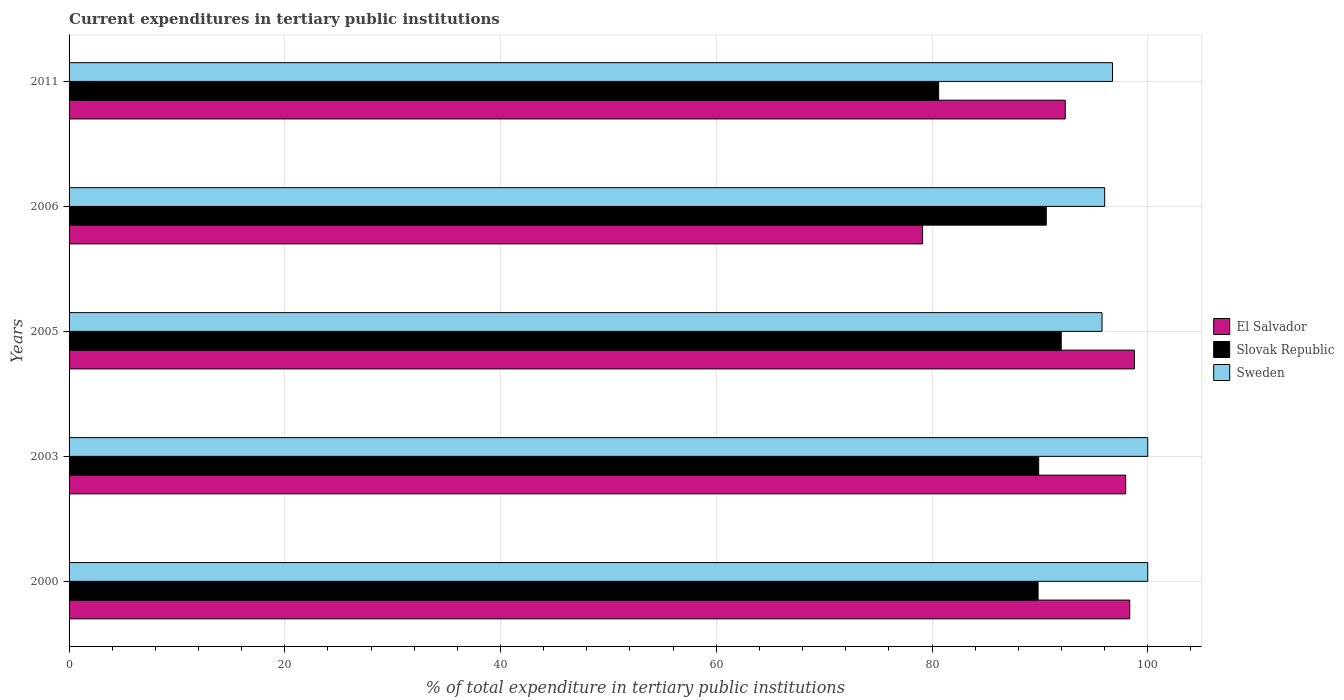How many different coloured bars are there?
Ensure brevity in your answer.  3. Are the number of bars on each tick of the Y-axis equal?
Provide a short and direct response. Yes. How many bars are there on the 4th tick from the top?
Make the answer very short. 3. How many bars are there on the 5th tick from the bottom?
Offer a terse response. 3. What is the label of the 1st group of bars from the top?
Your answer should be very brief. 2011. What is the current expenditures in tertiary public institutions in Slovak Republic in 2000?
Ensure brevity in your answer.  89.83. Across all years, what is the maximum current expenditures in tertiary public institutions in El Salvador?
Your response must be concise. 98.76. Across all years, what is the minimum current expenditures in tertiary public institutions in Slovak Republic?
Provide a succinct answer. 80.62. In which year was the current expenditures in tertiary public institutions in Sweden maximum?
Provide a succinct answer. 2000. In which year was the current expenditures in tertiary public institutions in Sweden minimum?
Provide a short and direct response. 2005. What is the total current expenditures in tertiary public institutions in El Salvador in the graph?
Keep it short and to the point. 466.52. What is the difference between the current expenditures in tertiary public institutions in Sweden in 2005 and that in 2011?
Keep it short and to the point. -0.97. What is the difference between the current expenditures in tertiary public institutions in Sweden in 2005 and the current expenditures in tertiary public institutions in El Salvador in 2000?
Provide a succinct answer. -2.57. What is the average current expenditures in tertiary public institutions in Slovak Republic per year?
Give a very brief answer. 88.58. In the year 2006, what is the difference between the current expenditures in tertiary public institutions in El Salvador and current expenditures in tertiary public institutions in Slovak Republic?
Your answer should be compact. -11.47. What is the ratio of the current expenditures in tertiary public institutions in Slovak Republic in 2000 to that in 2006?
Offer a terse response. 0.99. Is the current expenditures in tertiary public institutions in Sweden in 2003 less than that in 2005?
Your answer should be very brief. No. Is the difference between the current expenditures in tertiary public institutions in El Salvador in 2006 and 2011 greater than the difference between the current expenditures in tertiary public institutions in Slovak Republic in 2006 and 2011?
Give a very brief answer. No. What is the difference between the highest and the second highest current expenditures in tertiary public institutions in Sweden?
Your response must be concise. 0. What is the difference between the highest and the lowest current expenditures in tertiary public institutions in El Salvador?
Your answer should be very brief. 19.63. In how many years, is the current expenditures in tertiary public institutions in Sweden greater than the average current expenditures in tertiary public institutions in Sweden taken over all years?
Keep it short and to the point. 2. Is the sum of the current expenditures in tertiary public institutions in Slovak Republic in 2003 and 2006 greater than the maximum current expenditures in tertiary public institutions in El Salvador across all years?
Keep it short and to the point. Yes. What does the 3rd bar from the top in 2006 represents?
Your answer should be compact. El Salvador. What does the 3rd bar from the bottom in 2000 represents?
Offer a very short reply. Sweden. Is it the case that in every year, the sum of the current expenditures in tertiary public institutions in El Salvador and current expenditures in tertiary public institutions in Sweden is greater than the current expenditures in tertiary public institutions in Slovak Republic?
Make the answer very short. Yes. How many years are there in the graph?
Make the answer very short. 5. Does the graph contain any zero values?
Provide a short and direct response. No. Does the graph contain grids?
Offer a very short reply. Yes. How many legend labels are there?
Offer a very short reply. 3. What is the title of the graph?
Ensure brevity in your answer.  Current expenditures in tertiary public institutions. What is the label or title of the X-axis?
Provide a succinct answer. % of total expenditure in tertiary public institutions. What is the % of total expenditure in tertiary public institutions of El Salvador in 2000?
Offer a very short reply. 98.33. What is the % of total expenditure in tertiary public institutions of Slovak Republic in 2000?
Ensure brevity in your answer.  89.83. What is the % of total expenditure in tertiary public institutions of El Salvador in 2003?
Give a very brief answer. 97.95. What is the % of total expenditure in tertiary public institutions of Slovak Republic in 2003?
Offer a very short reply. 89.89. What is the % of total expenditure in tertiary public institutions in El Salvador in 2005?
Provide a short and direct response. 98.76. What is the % of total expenditure in tertiary public institutions in Slovak Republic in 2005?
Provide a succinct answer. 91.98. What is the % of total expenditure in tertiary public institutions of Sweden in 2005?
Keep it short and to the point. 95.76. What is the % of total expenditure in tertiary public institutions in El Salvador in 2006?
Provide a succinct answer. 79.13. What is the % of total expenditure in tertiary public institutions in Slovak Republic in 2006?
Keep it short and to the point. 90.59. What is the % of total expenditure in tertiary public institutions of Sweden in 2006?
Offer a terse response. 96.01. What is the % of total expenditure in tertiary public institutions in El Salvador in 2011?
Keep it short and to the point. 92.35. What is the % of total expenditure in tertiary public institutions in Slovak Republic in 2011?
Provide a succinct answer. 80.62. What is the % of total expenditure in tertiary public institutions in Sweden in 2011?
Your response must be concise. 96.74. Across all years, what is the maximum % of total expenditure in tertiary public institutions of El Salvador?
Make the answer very short. 98.76. Across all years, what is the maximum % of total expenditure in tertiary public institutions in Slovak Republic?
Your response must be concise. 91.98. Across all years, what is the minimum % of total expenditure in tertiary public institutions in El Salvador?
Offer a very short reply. 79.13. Across all years, what is the minimum % of total expenditure in tertiary public institutions in Slovak Republic?
Your response must be concise. 80.62. Across all years, what is the minimum % of total expenditure in tertiary public institutions of Sweden?
Provide a succinct answer. 95.76. What is the total % of total expenditure in tertiary public institutions of El Salvador in the graph?
Provide a succinct answer. 466.52. What is the total % of total expenditure in tertiary public institutions of Slovak Republic in the graph?
Your response must be concise. 442.91. What is the total % of total expenditure in tertiary public institutions of Sweden in the graph?
Offer a terse response. 488.5. What is the difference between the % of total expenditure in tertiary public institutions of El Salvador in 2000 and that in 2003?
Offer a terse response. 0.38. What is the difference between the % of total expenditure in tertiary public institutions in Slovak Republic in 2000 and that in 2003?
Offer a very short reply. -0.06. What is the difference between the % of total expenditure in tertiary public institutions in Sweden in 2000 and that in 2003?
Offer a terse response. 0. What is the difference between the % of total expenditure in tertiary public institutions of El Salvador in 2000 and that in 2005?
Ensure brevity in your answer.  -0.43. What is the difference between the % of total expenditure in tertiary public institutions of Slovak Republic in 2000 and that in 2005?
Give a very brief answer. -2.15. What is the difference between the % of total expenditure in tertiary public institutions in Sweden in 2000 and that in 2005?
Ensure brevity in your answer.  4.24. What is the difference between the % of total expenditure in tertiary public institutions in El Salvador in 2000 and that in 2006?
Offer a very short reply. 19.2. What is the difference between the % of total expenditure in tertiary public institutions in Slovak Republic in 2000 and that in 2006?
Make the answer very short. -0.76. What is the difference between the % of total expenditure in tertiary public institutions in Sweden in 2000 and that in 2006?
Make the answer very short. 3.99. What is the difference between the % of total expenditure in tertiary public institutions in El Salvador in 2000 and that in 2011?
Make the answer very short. 5.98. What is the difference between the % of total expenditure in tertiary public institutions of Slovak Republic in 2000 and that in 2011?
Provide a short and direct response. 9.22. What is the difference between the % of total expenditure in tertiary public institutions in Sweden in 2000 and that in 2011?
Your answer should be very brief. 3.26. What is the difference between the % of total expenditure in tertiary public institutions of El Salvador in 2003 and that in 2005?
Provide a short and direct response. -0.8. What is the difference between the % of total expenditure in tertiary public institutions of Slovak Republic in 2003 and that in 2005?
Offer a terse response. -2.09. What is the difference between the % of total expenditure in tertiary public institutions in Sweden in 2003 and that in 2005?
Your answer should be very brief. 4.24. What is the difference between the % of total expenditure in tertiary public institutions of El Salvador in 2003 and that in 2006?
Your answer should be compact. 18.83. What is the difference between the % of total expenditure in tertiary public institutions of Slovak Republic in 2003 and that in 2006?
Ensure brevity in your answer.  -0.71. What is the difference between the % of total expenditure in tertiary public institutions in Sweden in 2003 and that in 2006?
Offer a terse response. 3.99. What is the difference between the % of total expenditure in tertiary public institutions of El Salvador in 2003 and that in 2011?
Offer a very short reply. 5.6. What is the difference between the % of total expenditure in tertiary public institutions in Slovak Republic in 2003 and that in 2011?
Your response must be concise. 9.27. What is the difference between the % of total expenditure in tertiary public institutions of Sweden in 2003 and that in 2011?
Offer a very short reply. 3.26. What is the difference between the % of total expenditure in tertiary public institutions of El Salvador in 2005 and that in 2006?
Offer a very short reply. 19.63. What is the difference between the % of total expenditure in tertiary public institutions in Slovak Republic in 2005 and that in 2006?
Give a very brief answer. 1.39. What is the difference between the % of total expenditure in tertiary public institutions of Sweden in 2005 and that in 2006?
Your response must be concise. -0.24. What is the difference between the % of total expenditure in tertiary public institutions in El Salvador in 2005 and that in 2011?
Your answer should be very brief. 6.4. What is the difference between the % of total expenditure in tertiary public institutions of Slovak Republic in 2005 and that in 2011?
Provide a succinct answer. 11.36. What is the difference between the % of total expenditure in tertiary public institutions in Sweden in 2005 and that in 2011?
Provide a succinct answer. -0.97. What is the difference between the % of total expenditure in tertiary public institutions of El Salvador in 2006 and that in 2011?
Provide a succinct answer. -13.23. What is the difference between the % of total expenditure in tertiary public institutions of Slovak Republic in 2006 and that in 2011?
Make the answer very short. 9.98. What is the difference between the % of total expenditure in tertiary public institutions in Sweden in 2006 and that in 2011?
Ensure brevity in your answer.  -0.73. What is the difference between the % of total expenditure in tertiary public institutions in El Salvador in 2000 and the % of total expenditure in tertiary public institutions in Slovak Republic in 2003?
Make the answer very short. 8.44. What is the difference between the % of total expenditure in tertiary public institutions of El Salvador in 2000 and the % of total expenditure in tertiary public institutions of Sweden in 2003?
Your answer should be compact. -1.67. What is the difference between the % of total expenditure in tertiary public institutions of Slovak Republic in 2000 and the % of total expenditure in tertiary public institutions of Sweden in 2003?
Give a very brief answer. -10.17. What is the difference between the % of total expenditure in tertiary public institutions in El Salvador in 2000 and the % of total expenditure in tertiary public institutions in Slovak Republic in 2005?
Provide a succinct answer. 6.35. What is the difference between the % of total expenditure in tertiary public institutions in El Salvador in 2000 and the % of total expenditure in tertiary public institutions in Sweden in 2005?
Offer a very short reply. 2.57. What is the difference between the % of total expenditure in tertiary public institutions of Slovak Republic in 2000 and the % of total expenditure in tertiary public institutions of Sweden in 2005?
Provide a short and direct response. -5.93. What is the difference between the % of total expenditure in tertiary public institutions in El Salvador in 2000 and the % of total expenditure in tertiary public institutions in Slovak Republic in 2006?
Your answer should be compact. 7.74. What is the difference between the % of total expenditure in tertiary public institutions in El Salvador in 2000 and the % of total expenditure in tertiary public institutions in Sweden in 2006?
Your answer should be very brief. 2.32. What is the difference between the % of total expenditure in tertiary public institutions of Slovak Republic in 2000 and the % of total expenditure in tertiary public institutions of Sweden in 2006?
Offer a terse response. -6.17. What is the difference between the % of total expenditure in tertiary public institutions in El Salvador in 2000 and the % of total expenditure in tertiary public institutions in Slovak Republic in 2011?
Your response must be concise. 17.72. What is the difference between the % of total expenditure in tertiary public institutions in El Salvador in 2000 and the % of total expenditure in tertiary public institutions in Sweden in 2011?
Provide a short and direct response. 1.6. What is the difference between the % of total expenditure in tertiary public institutions of Slovak Republic in 2000 and the % of total expenditure in tertiary public institutions of Sweden in 2011?
Make the answer very short. -6.9. What is the difference between the % of total expenditure in tertiary public institutions in El Salvador in 2003 and the % of total expenditure in tertiary public institutions in Slovak Republic in 2005?
Ensure brevity in your answer.  5.97. What is the difference between the % of total expenditure in tertiary public institutions of El Salvador in 2003 and the % of total expenditure in tertiary public institutions of Sweden in 2005?
Your response must be concise. 2.19. What is the difference between the % of total expenditure in tertiary public institutions of Slovak Republic in 2003 and the % of total expenditure in tertiary public institutions of Sweden in 2005?
Your answer should be compact. -5.87. What is the difference between the % of total expenditure in tertiary public institutions in El Salvador in 2003 and the % of total expenditure in tertiary public institutions in Slovak Republic in 2006?
Your response must be concise. 7.36. What is the difference between the % of total expenditure in tertiary public institutions of El Salvador in 2003 and the % of total expenditure in tertiary public institutions of Sweden in 2006?
Give a very brief answer. 1.95. What is the difference between the % of total expenditure in tertiary public institutions of Slovak Republic in 2003 and the % of total expenditure in tertiary public institutions of Sweden in 2006?
Provide a short and direct response. -6.12. What is the difference between the % of total expenditure in tertiary public institutions in El Salvador in 2003 and the % of total expenditure in tertiary public institutions in Slovak Republic in 2011?
Give a very brief answer. 17.34. What is the difference between the % of total expenditure in tertiary public institutions of El Salvador in 2003 and the % of total expenditure in tertiary public institutions of Sweden in 2011?
Offer a terse response. 1.22. What is the difference between the % of total expenditure in tertiary public institutions of Slovak Republic in 2003 and the % of total expenditure in tertiary public institutions of Sweden in 2011?
Your answer should be very brief. -6.85. What is the difference between the % of total expenditure in tertiary public institutions in El Salvador in 2005 and the % of total expenditure in tertiary public institutions in Slovak Republic in 2006?
Make the answer very short. 8.16. What is the difference between the % of total expenditure in tertiary public institutions of El Salvador in 2005 and the % of total expenditure in tertiary public institutions of Sweden in 2006?
Your response must be concise. 2.75. What is the difference between the % of total expenditure in tertiary public institutions of Slovak Republic in 2005 and the % of total expenditure in tertiary public institutions of Sweden in 2006?
Ensure brevity in your answer.  -4.03. What is the difference between the % of total expenditure in tertiary public institutions of El Salvador in 2005 and the % of total expenditure in tertiary public institutions of Slovak Republic in 2011?
Your answer should be very brief. 18.14. What is the difference between the % of total expenditure in tertiary public institutions of El Salvador in 2005 and the % of total expenditure in tertiary public institutions of Sweden in 2011?
Your answer should be compact. 2.02. What is the difference between the % of total expenditure in tertiary public institutions in Slovak Republic in 2005 and the % of total expenditure in tertiary public institutions in Sweden in 2011?
Offer a very short reply. -4.76. What is the difference between the % of total expenditure in tertiary public institutions of El Salvador in 2006 and the % of total expenditure in tertiary public institutions of Slovak Republic in 2011?
Your answer should be compact. -1.49. What is the difference between the % of total expenditure in tertiary public institutions of El Salvador in 2006 and the % of total expenditure in tertiary public institutions of Sweden in 2011?
Your answer should be very brief. -17.61. What is the difference between the % of total expenditure in tertiary public institutions of Slovak Republic in 2006 and the % of total expenditure in tertiary public institutions of Sweden in 2011?
Give a very brief answer. -6.14. What is the average % of total expenditure in tertiary public institutions in El Salvador per year?
Offer a terse response. 93.3. What is the average % of total expenditure in tertiary public institutions of Slovak Republic per year?
Give a very brief answer. 88.58. What is the average % of total expenditure in tertiary public institutions in Sweden per year?
Give a very brief answer. 97.7. In the year 2000, what is the difference between the % of total expenditure in tertiary public institutions in El Salvador and % of total expenditure in tertiary public institutions in Slovak Republic?
Give a very brief answer. 8.5. In the year 2000, what is the difference between the % of total expenditure in tertiary public institutions in El Salvador and % of total expenditure in tertiary public institutions in Sweden?
Offer a very short reply. -1.67. In the year 2000, what is the difference between the % of total expenditure in tertiary public institutions in Slovak Republic and % of total expenditure in tertiary public institutions in Sweden?
Keep it short and to the point. -10.17. In the year 2003, what is the difference between the % of total expenditure in tertiary public institutions in El Salvador and % of total expenditure in tertiary public institutions in Slovak Republic?
Provide a succinct answer. 8.07. In the year 2003, what is the difference between the % of total expenditure in tertiary public institutions in El Salvador and % of total expenditure in tertiary public institutions in Sweden?
Your answer should be compact. -2.05. In the year 2003, what is the difference between the % of total expenditure in tertiary public institutions in Slovak Republic and % of total expenditure in tertiary public institutions in Sweden?
Give a very brief answer. -10.11. In the year 2005, what is the difference between the % of total expenditure in tertiary public institutions in El Salvador and % of total expenditure in tertiary public institutions in Slovak Republic?
Your answer should be compact. 6.78. In the year 2005, what is the difference between the % of total expenditure in tertiary public institutions of El Salvador and % of total expenditure in tertiary public institutions of Sweden?
Give a very brief answer. 3. In the year 2005, what is the difference between the % of total expenditure in tertiary public institutions of Slovak Republic and % of total expenditure in tertiary public institutions of Sweden?
Your response must be concise. -3.78. In the year 2006, what is the difference between the % of total expenditure in tertiary public institutions in El Salvador and % of total expenditure in tertiary public institutions in Slovak Republic?
Your response must be concise. -11.47. In the year 2006, what is the difference between the % of total expenditure in tertiary public institutions of El Salvador and % of total expenditure in tertiary public institutions of Sweden?
Provide a short and direct response. -16.88. In the year 2006, what is the difference between the % of total expenditure in tertiary public institutions of Slovak Republic and % of total expenditure in tertiary public institutions of Sweden?
Offer a very short reply. -5.41. In the year 2011, what is the difference between the % of total expenditure in tertiary public institutions in El Salvador and % of total expenditure in tertiary public institutions in Slovak Republic?
Provide a short and direct response. 11.74. In the year 2011, what is the difference between the % of total expenditure in tertiary public institutions of El Salvador and % of total expenditure in tertiary public institutions of Sweden?
Ensure brevity in your answer.  -4.38. In the year 2011, what is the difference between the % of total expenditure in tertiary public institutions in Slovak Republic and % of total expenditure in tertiary public institutions in Sweden?
Give a very brief answer. -16.12. What is the ratio of the % of total expenditure in tertiary public institutions in Slovak Republic in 2000 to that in 2003?
Offer a very short reply. 1. What is the ratio of the % of total expenditure in tertiary public institutions of Sweden in 2000 to that in 2003?
Give a very brief answer. 1. What is the ratio of the % of total expenditure in tertiary public institutions of El Salvador in 2000 to that in 2005?
Provide a short and direct response. 1. What is the ratio of the % of total expenditure in tertiary public institutions in Slovak Republic in 2000 to that in 2005?
Make the answer very short. 0.98. What is the ratio of the % of total expenditure in tertiary public institutions in Sweden in 2000 to that in 2005?
Provide a short and direct response. 1.04. What is the ratio of the % of total expenditure in tertiary public institutions of El Salvador in 2000 to that in 2006?
Your answer should be very brief. 1.24. What is the ratio of the % of total expenditure in tertiary public institutions of Sweden in 2000 to that in 2006?
Offer a very short reply. 1.04. What is the ratio of the % of total expenditure in tertiary public institutions in El Salvador in 2000 to that in 2011?
Make the answer very short. 1.06. What is the ratio of the % of total expenditure in tertiary public institutions in Slovak Republic in 2000 to that in 2011?
Offer a very short reply. 1.11. What is the ratio of the % of total expenditure in tertiary public institutions in Sweden in 2000 to that in 2011?
Provide a short and direct response. 1.03. What is the ratio of the % of total expenditure in tertiary public institutions of El Salvador in 2003 to that in 2005?
Give a very brief answer. 0.99. What is the ratio of the % of total expenditure in tertiary public institutions of Slovak Republic in 2003 to that in 2005?
Offer a very short reply. 0.98. What is the ratio of the % of total expenditure in tertiary public institutions of Sweden in 2003 to that in 2005?
Offer a very short reply. 1.04. What is the ratio of the % of total expenditure in tertiary public institutions of El Salvador in 2003 to that in 2006?
Provide a short and direct response. 1.24. What is the ratio of the % of total expenditure in tertiary public institutions in Slovak Republic in 2003 to that in 2006?
Offer a terse response. 0.99. What is the ratio of the % of total expenditure in tertiary public institutions of Sweden in 2003 to that in 2006?
Offer a very short reply. 1.04. What is the ratio of the % of total expenditure in tertiary public institutions in El Salvador in 2003 to that in 2011?
Offer a very short reply. 1.06. What is the ratio of the % of total expenditure in tertiary public institutions in Slovak Republic in 2003 to that in 2011?
Keep it short and to the point. 1.11. What is the ratio of the % of total expenditure in tertiary public institutions in Sweden in 2003 to that in 2011?
Your answer should be compact. 1.03. What is the ratio of the % of total expenditure in tertiary public institutions of El Salvador in 2005 to that in 2006?
Provide a short and direct response. 1.25. What is the ratio of the % of total expenditure in tertiary public institutions of Slovak Republic in 2005 to that in 2006?
Your response must be concise. 1.02. What is the ratio of the % of total expenditure in tertiary public institutions of Sweden in 2005 to that in 2006?
Your answer should be compact. 1. What is the ratio of the % of total expenditure in tertiary public institutions in El Salvador in 2005 to that in 2011?
Offer a terse response. 1.07. What is the ratio of the % of total expenditure in tertiary public institutions in Slovak Republic in 2005 to that in 2011?
Provide a short and direct response. 1.14. What is the ratio of the % of total expenditure in tertiary public institutions in Sweden in 2005 to that in 2011?
Your response must be concise. 0.99. What is the ratio of the % of total expenditure in tertiary public institutions of El Salvador in 2006 to that in 2011?
Keep it short and to the point. 0.86. What is the ratio of the % of total expenditure in tertiary public institutions of Slovak Republic in 2006 to that in 2011?
Ensure brevity in your answer.  1.12. What is the ratio of the % of total expenditure in tertiary public institutions of Sweden in 2006 to that in 2011?
Your answer should be very brief. 0.99. What is the difference between the highest and the second highest % of total expenditure in tertiary public institutions in El Salvador?
Your answer should be very brief. 0.43. What is the difference between the highest and the second highest % of total expenditure in tertiary public institutions in Slovak Republic?
Make the answer very short. 1.39. What is the difference between the highest and the lowest % of total expenditure in tertiary public institutions in El Salvador?
Your answer should be very brief. 19.63. What is the difference between the highest and the lowest % of total expenditure in tertiary public institutions in Slovak Republic?
Give a very brief answer. 11.36. What is the difference between the highest and the lowest % of total expenditure in tertiary public institutions in Sweden?
Your answer should be very brief. 4.24. 